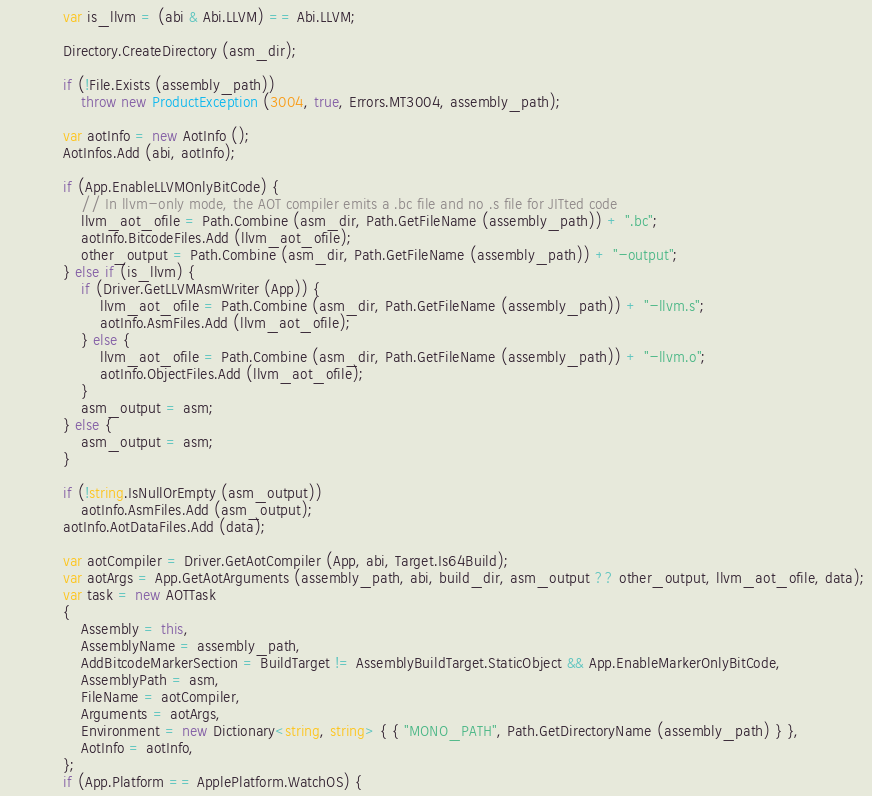Convert code to text. <code><loc_0><loc_0><loc_500><loc_500><_C#_>			var is_llvm = (abi & Abi.LLVM) == Abi.LLVM;

			Directory.CreateDirectory (asm_dir);

			if (!File.Exists (assembly_path))
				throw new ProductException (3004, true, Errors.MT3004, assembly_path);

			var aotInfo = new AotInfo ();
			AotInfos.Add (abi, aotInfo);

			if (App.EnableLLVMOnlyBitCode) {
				// In llvm-only mode, the AOT compiler emits a .bc file and no .s file for JITted code
				llvm_aot_ofile = Path.Combine (asm_dir, Path.GetFileName (assembly_path)) + ".bc";
				aotInfo.BitcodeFiles.Add (llvm_aot_ofile);
				other_output = Path.Combine (asm_dir, Path.GetFileName (assembly_path)) + "-output";
			} else if (is_llvm) {
				if (Driver.GetLLVMAsmWriter (App)) {
					llvm_aot_ofile = Path.Combine (asm_dir, Path.GetFileName (assembly_path)) + "-llvm.s";
					aotInfo.AsmFiles.Add (llvm_aot_ofile);
				} else {
					llvm_aot_ofile = Path.Combine (asm_dir, Path.GetFileName (assembly_path)) + "-llvm.o";
					aotInfo.ObjectFiles.Add (llvm_aot_ofile);
				}
				asm_output = asm;
			} else {
				asm_output = asm;
			}

			if (!string.IsNullOrEmpty (asm_output))
				aotInfo.AsmFiles.Add (asm_output);
			aotInfo.AotDataFiles.Add (data);

			var aotCompiler = Driver.GetAotCompiler (App, abi, Target.Is64Build);
			var aotArgs = App.GetAotArguments (assembly_path, abi, build_dir, asm_output ?? other_output, llvm_aot_ofile, data);
			var task = new AOTTask
			{
				Assembly = this,
				AssemblyName = assembly_path,
				AddBitcodeMarkerSection = BuildTarget != AssemblyBuildTarget.StaticObject && App.EnableMarkerOnlyBitCode,
				AssemblyPath = asm,
				FileName = aotCompiler,
				Arguments = aotArgs,
				Environment = new Dictionary<string, string> { { "MONO_PATH", Path.GetDirectoryName (assembly_path) } },
				AotInfo = aotInfo,
			};
			if (App.Platform == ApplePlatform.WatchOS) {</code> 